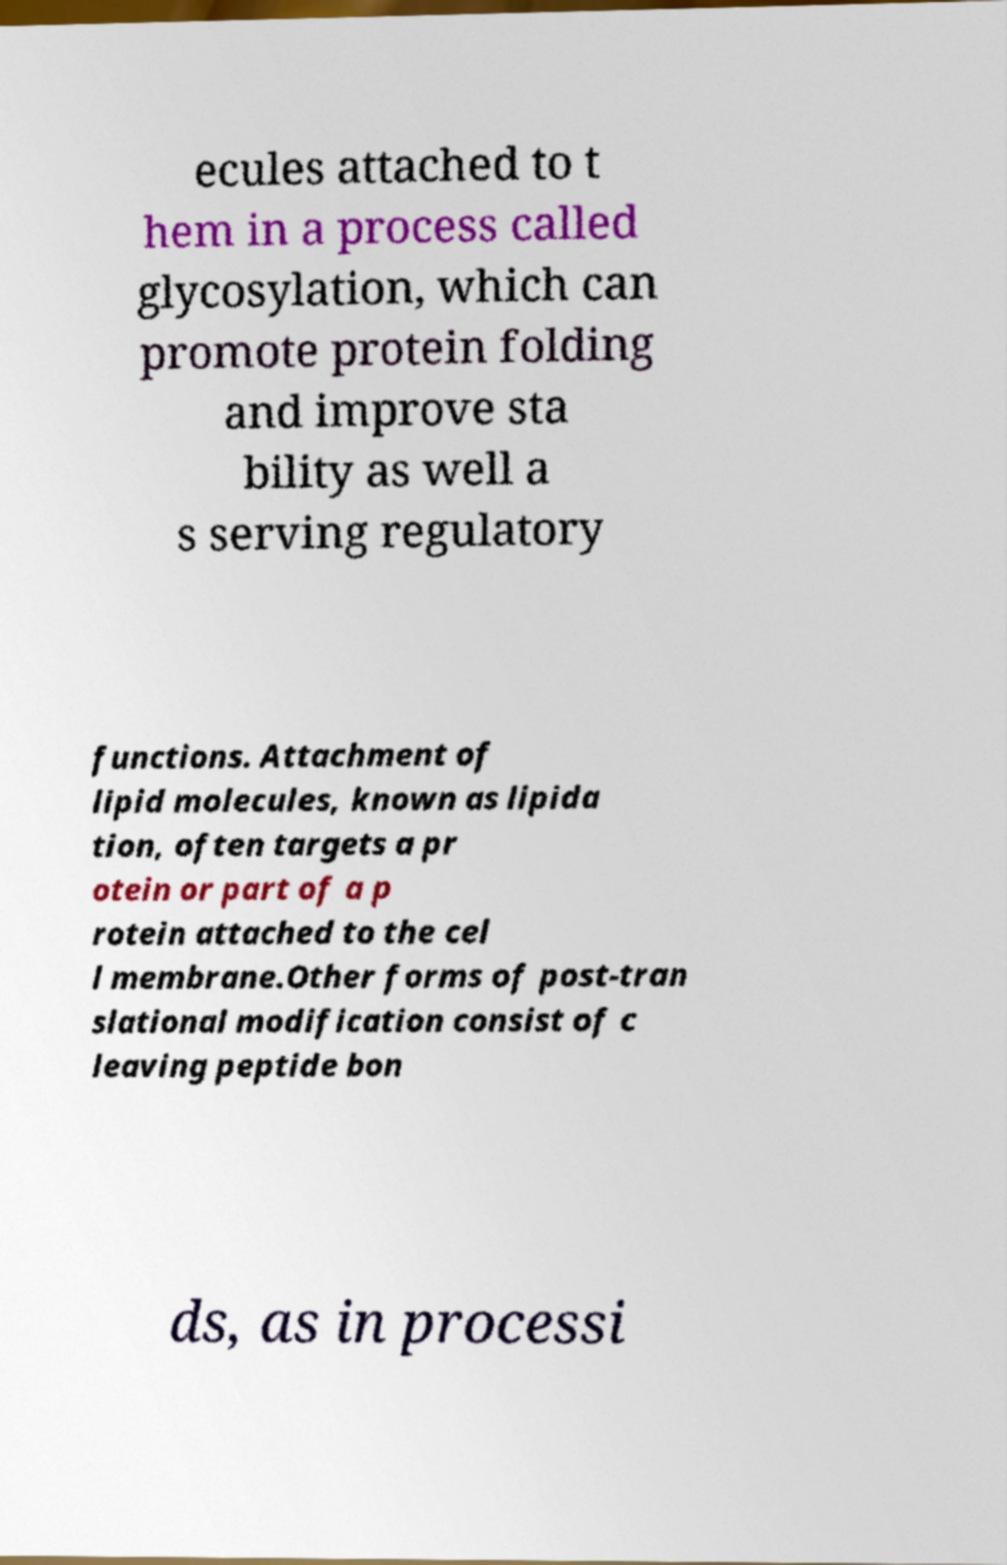Please identify and transcribe the text found in this image. ecules attached to t hem in a process called glycosylation, which can promote protein folding and improve sta bility as well a s serving regulatory functions. Attachment of lipid molecules, known as lipida tion, often targets a pr otein or part of a p rotein attached to the cel l membrane.Other forms of post-tran slational modification consist of c leaving peptide bon ds, as in processi 